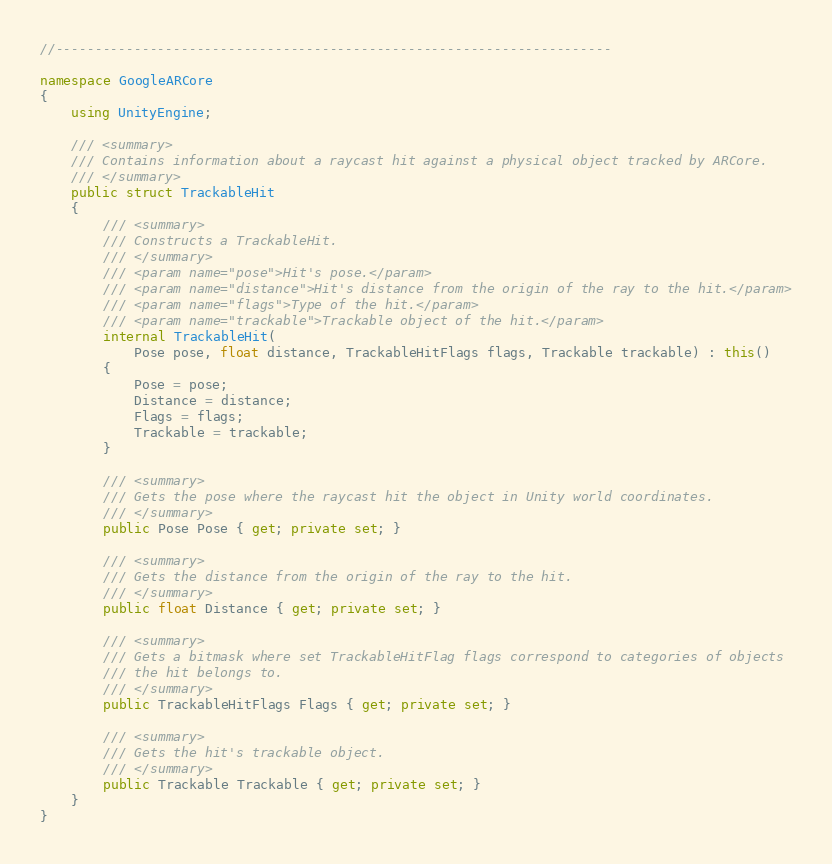Convert code to text. <code><loc_0><loc_0><loc_500><loc_500><_C#_>//-----------------------------------------------------------------------

namespace GoogleARCore
{
    using UnityEngine;

    /// <summary>
    /// Contains information about a raycast hit against a physical object tracked by ARCore.
    /// </summary>
    public struct TrackableHit
    {
        /// <summary>
        /// Constructs a TrackableHit.
        /// </summary>
        /// <param name="pose">Hit's pose.</param>
        /// <param name="distance">Hit's distance from the origin of the ray to the hit.</param>
        /// <param name="flags">Type of the hit.</param>
        /// <param name="trackable">Trackable object of the hit.</param>
        internal TrackableHit(
            Pose pose, float distance, TrackableHitFlags flags, Trackable trackable) : this()
        {
            Pose = pose;
            Distance = distance;
            Flags = flags;
            Trackable = trackable;
        }

        /// <summary>
        /// Gets the pose where the raycast hit the object in Unity world coordinates.
        /// </summary>
        public Pose Pose { get; private set; }

        /// <summary>
        /// Gets the distance from the origin of the ray to the hit.
        /// </summary>
        public float Distance { get; private set; }

        /// <summary>
        /// Gets a bitmask where set TrackableHitFlag flags correspond to categories of objects
        /// the hit belongs to.
        /// </summary>
        public TrackableHitFlags Flags { get; private set; }

        /// <summary>
        /// Gets the hit's trackable object.
        /// </summary>
        public Trackable Trackable { get; private set; }
    }
}
</code> 